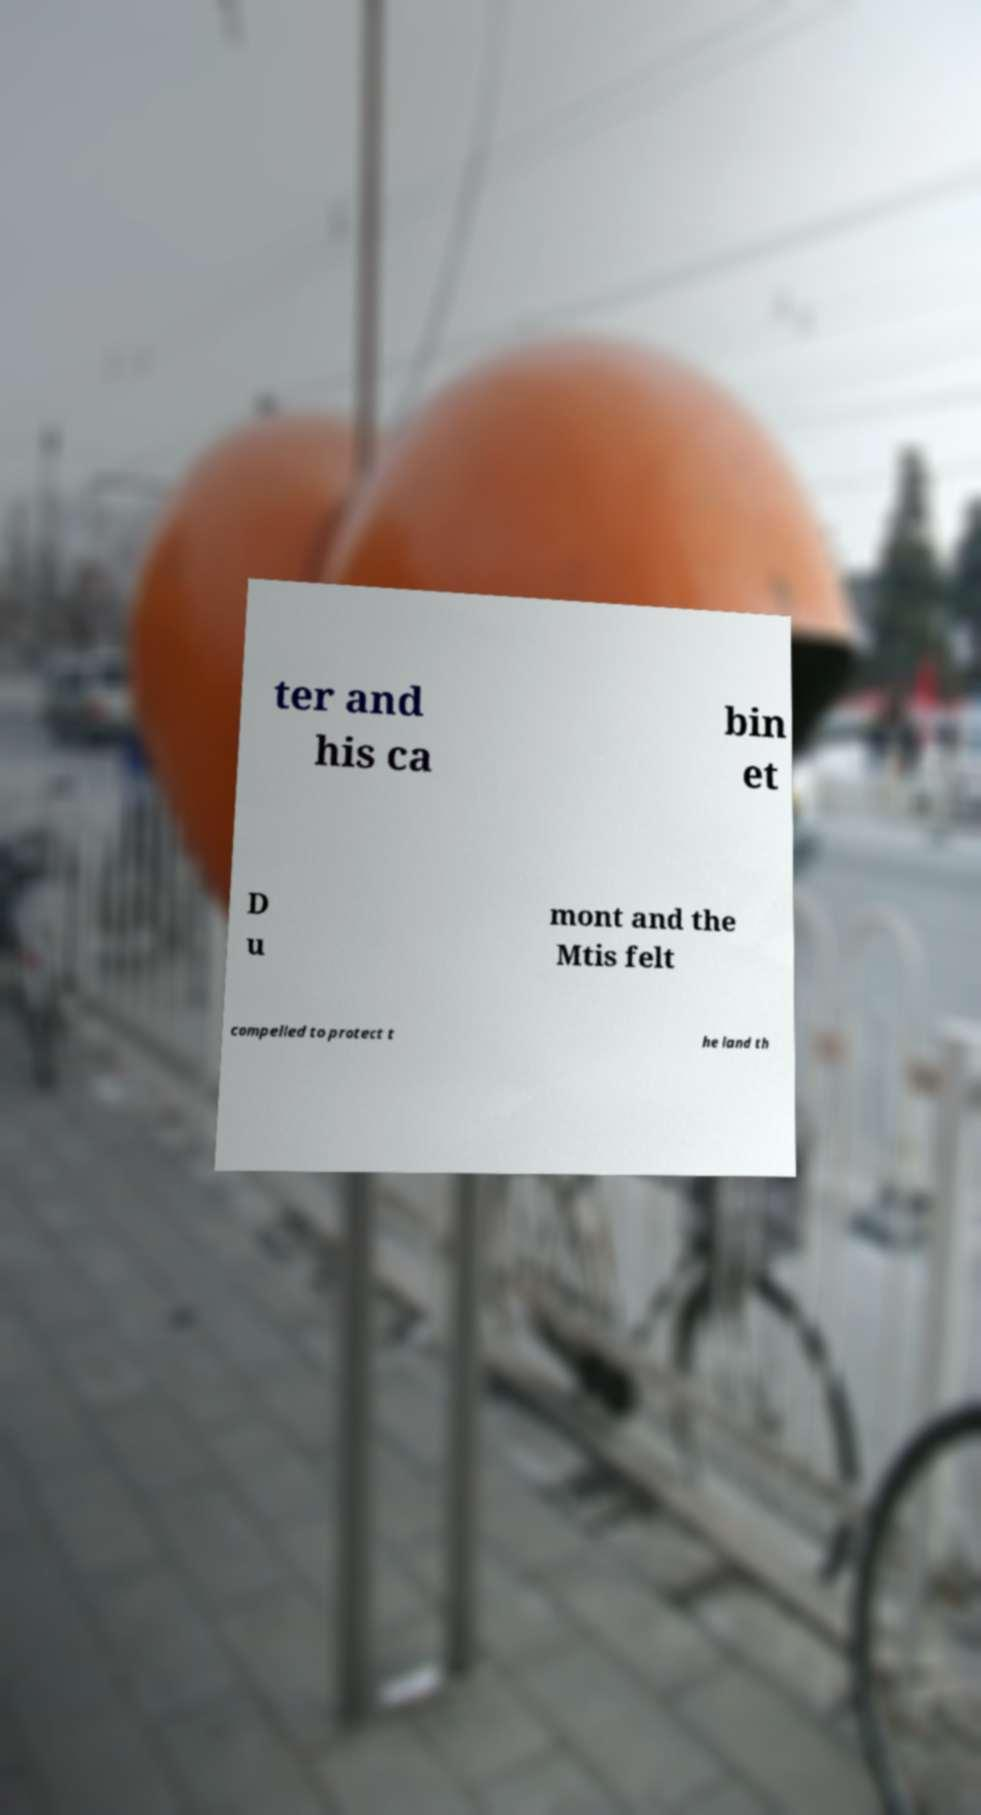What messages or text are displayed in this image? I need them in a readable, typed format. ter and his ca bin et D u mont and the Mtis felt compelled to protect t he land th 